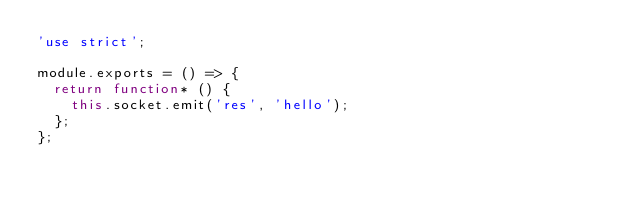<code> <loc_0><loc_0><loc_500><loc_500><_JavaScript_>'use strict';

module.exports = () => {
  return function* () {
    this.socket.emit('res', 'hello');
  };
};
</code> 